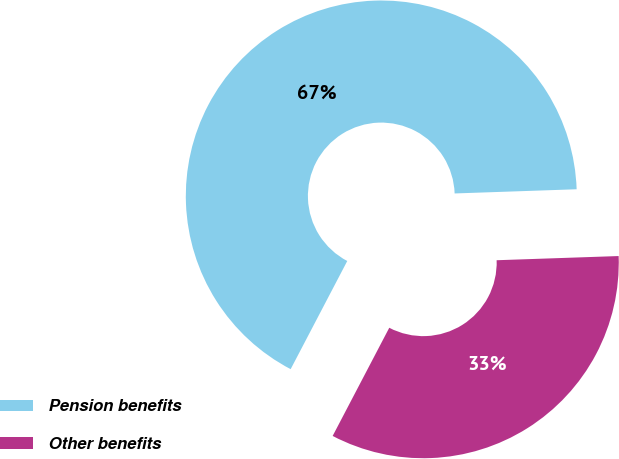Convert chart. <chart><loc_0><loc_0><loc_500><loc_500><pie_chart><fcel>Pension benefits<fcel>Other benefits<nl><fcel>66.78%<fcel>33.22%<nl></chart> 